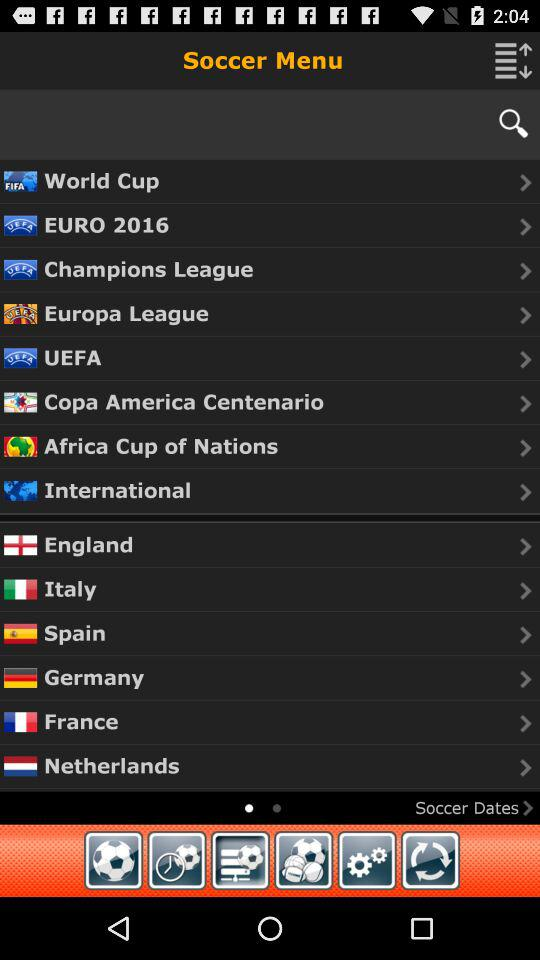What is the app name?
When the provided information is insufficient, respond with <no answer>. <no answer> 